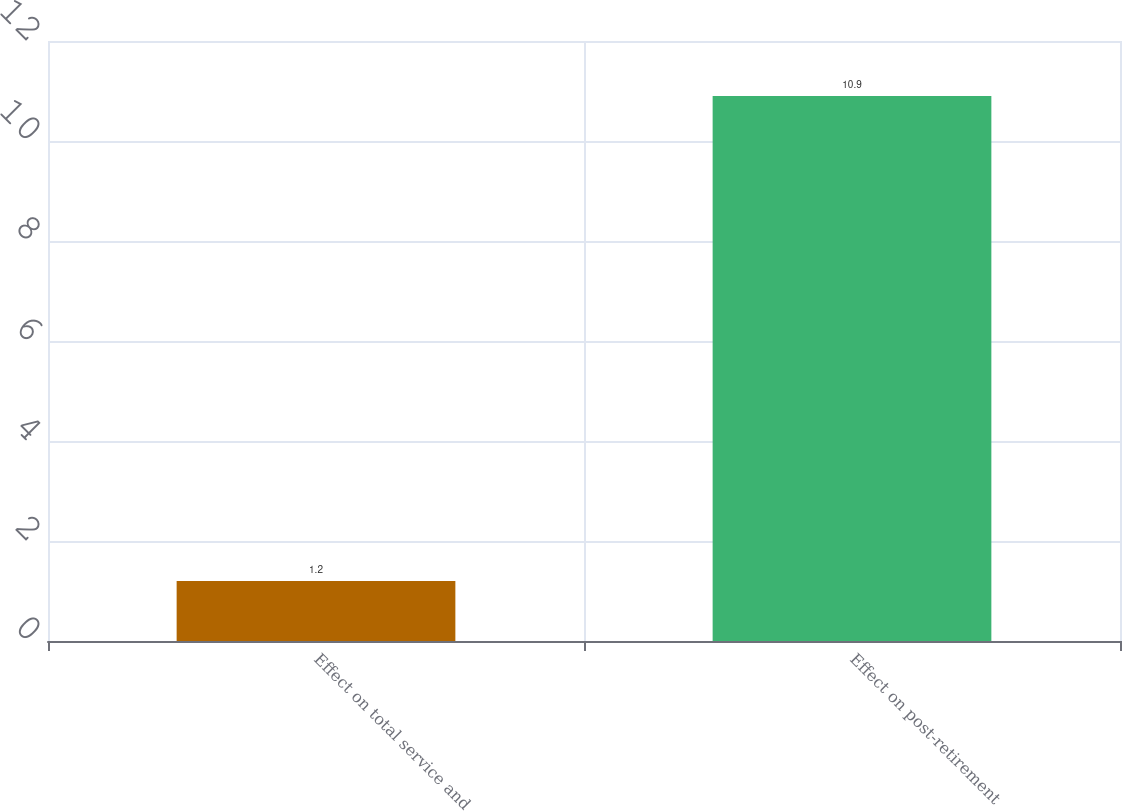Convert chart to OTSL. <chart><loc_0><loc_0><loc_500><loc_500><bar_chart><fcel>Effect on total service and<fcel>Effect on post-retirement<nl><fcel>1.2<fcel>10.9<nl></chart> 